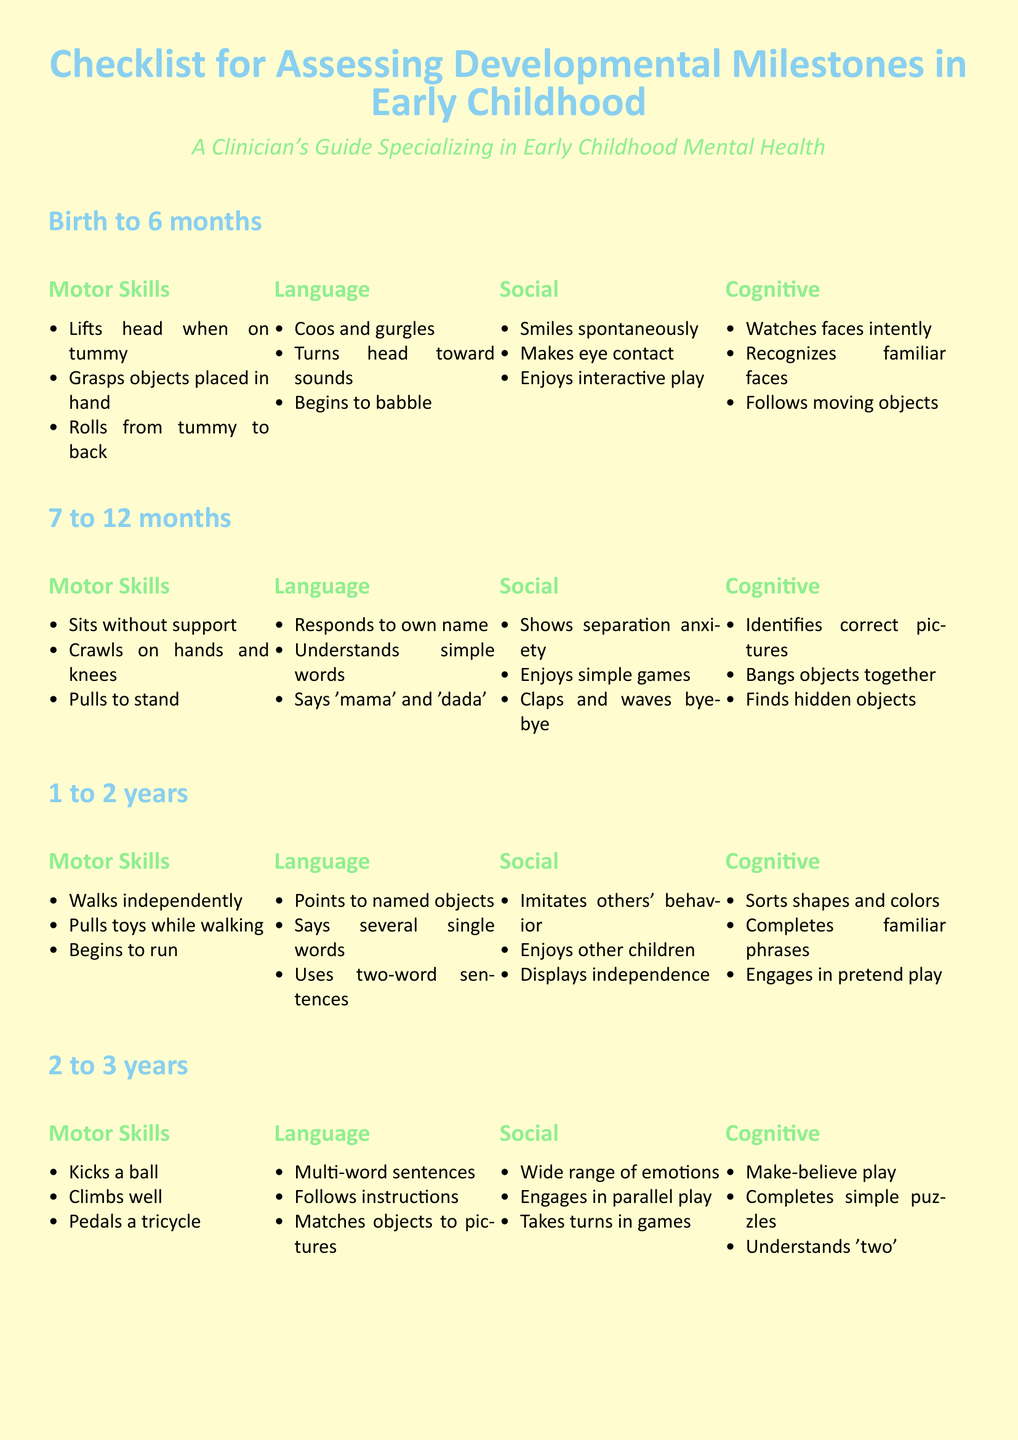what motor skill should a child demonstrate at 4 to 5 years old? The document lists several motor skills for this age group, one of which is "Hops on one foot."
Answer: Hops on one foot how many milestones are listed for language acquisition from birth to 6 months? The document provides three specific language milestones for this age group.
Answer: 3 what age range is assessed for cognitive abilities that include engaging in pretend play? The document specifies cognitive abilities and notes that engaging in pretend play is assessed for children aged 1 to 2 years.
Answer: 1 to 2 years what social skill is demonstrated by a child who enjoys simple games at 7 to 12 months? The document highlights "Enjoys simple games" as a social milestone for this age group.
Answer: Enjoys simple games which developmental milestone involves a child speaking clearly? The document states that "Speaks clearly" is a linguistic ability expected at 4 to 5 years.
Answer: Speaks clearly what is the primary focus of the document? The document is a checklist designed for clinicians to evaluate key developmental milestones in early childhood.
Answer: Checklist for Assessing Developmental Milestones in Early Childhood how many different age groups are covered in the document? The document covers five distinct age groups, each with specific milestones.
Answer: 5 which ability is associated with children aged 2 to 3 years in the cognitive section? The document lists "Make-believe play" as a cognitive ability for this age range.
Answer: Make-believe play 